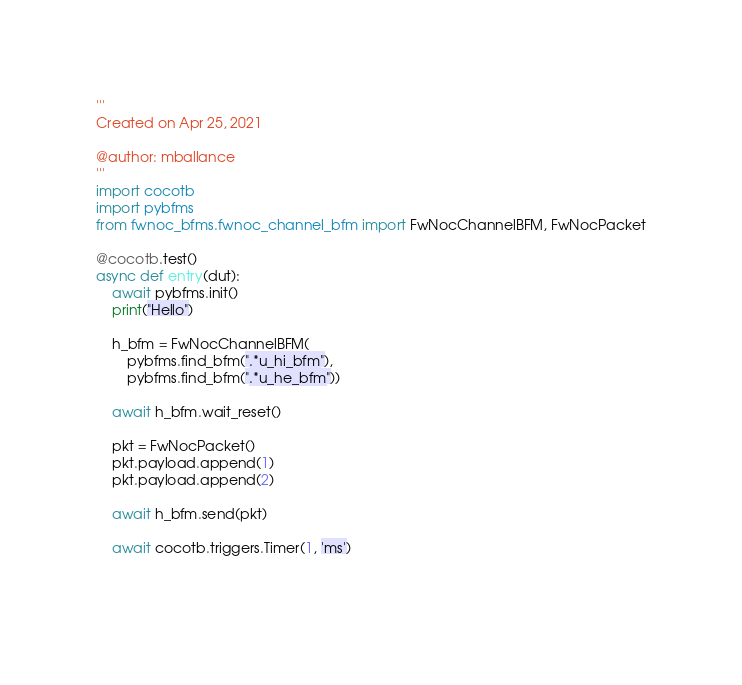Convert code to text. <code><loc_0><loc_0><loc_500><loc_500><_Python_>'''
Created on Apr 25, 2021

@author: mballance
'''
import cocotb
import pybfms
from fwnoc_bfms.fwnoc_channel_bfm import FwNocChannelBFM, FwNocPacket

@cocotb.test()
async def entry(dut):
    await pybfms.init()
    print("Hello")
    
    h_bfm = FwNocChannelBFM(
        pybfms.find_bfm(".*u_hi_bfm"),
        pybfms.find_bfm(".*u_he_bfm"))
    
    await h_bfm.wait_reset()
    
    pkt = FwNocPacket()
    pkt.payload.append(1)
    pkt.payload.append(2)
    
    await h_bfm.send(pkt)
    
    await cocotb.triggers.Timer(1, 'ms')
    
    </code> 